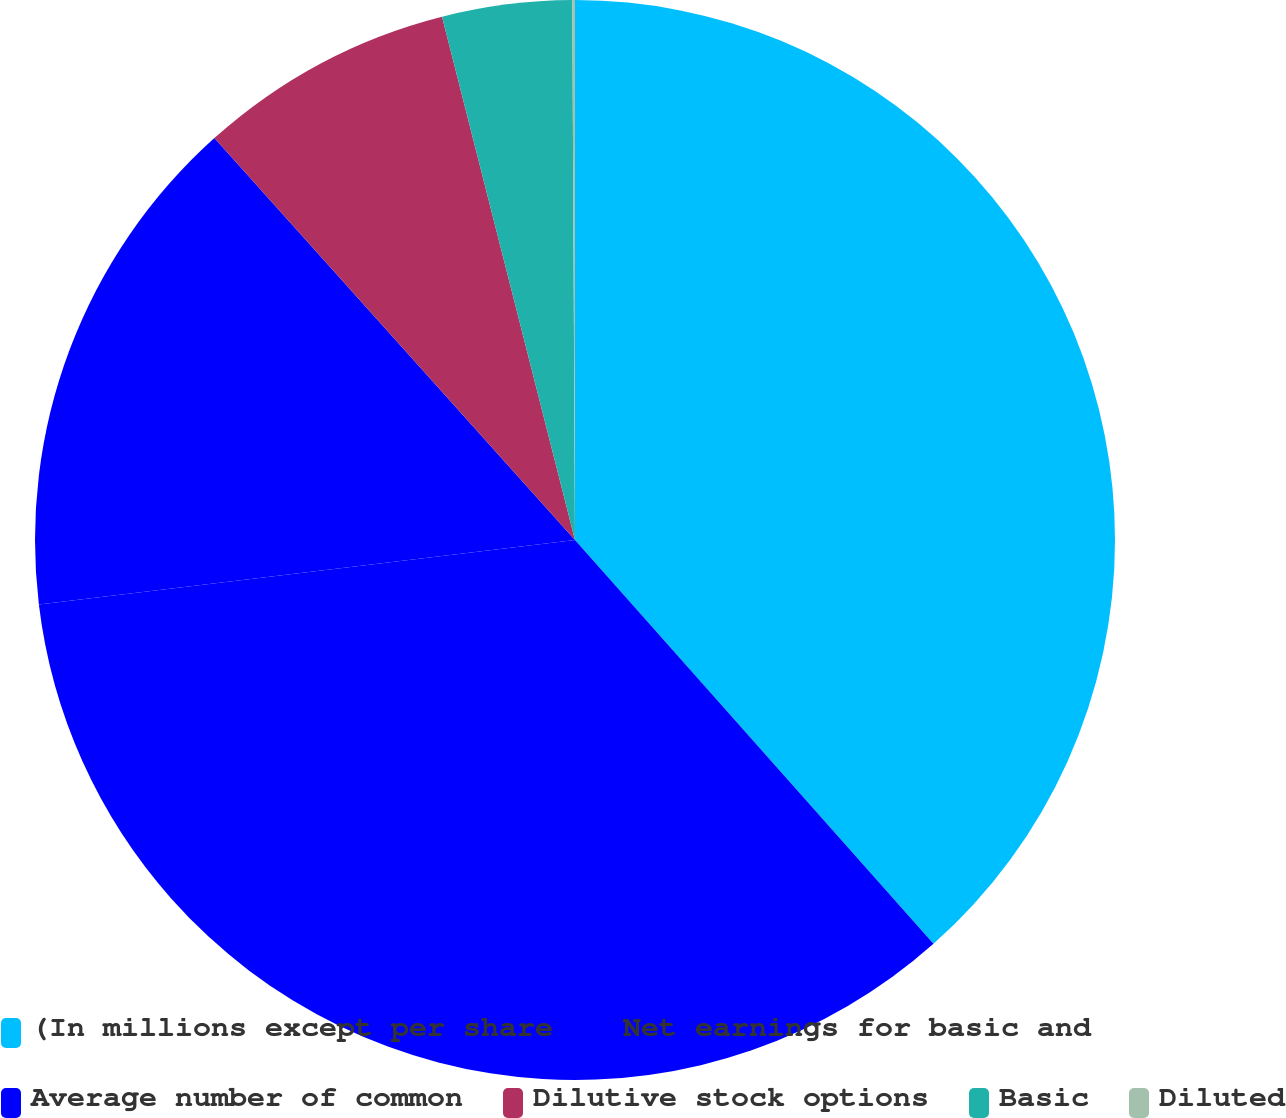<chart> <loc_0><loc_0><loc_500><loc_500><pie_chart><fcel>(In millions except per share<fcel>Net earnings for basic and<fcel>Average number of common<fcel>Dilutive stock options<fcel>Basic<fcel>Diluted<nl><fcel>38.45%<fcel>34.65%<fcel>15.27%<fcel>7.68%<fcel>3.88%<fcel>0.08%<nl></chart> 